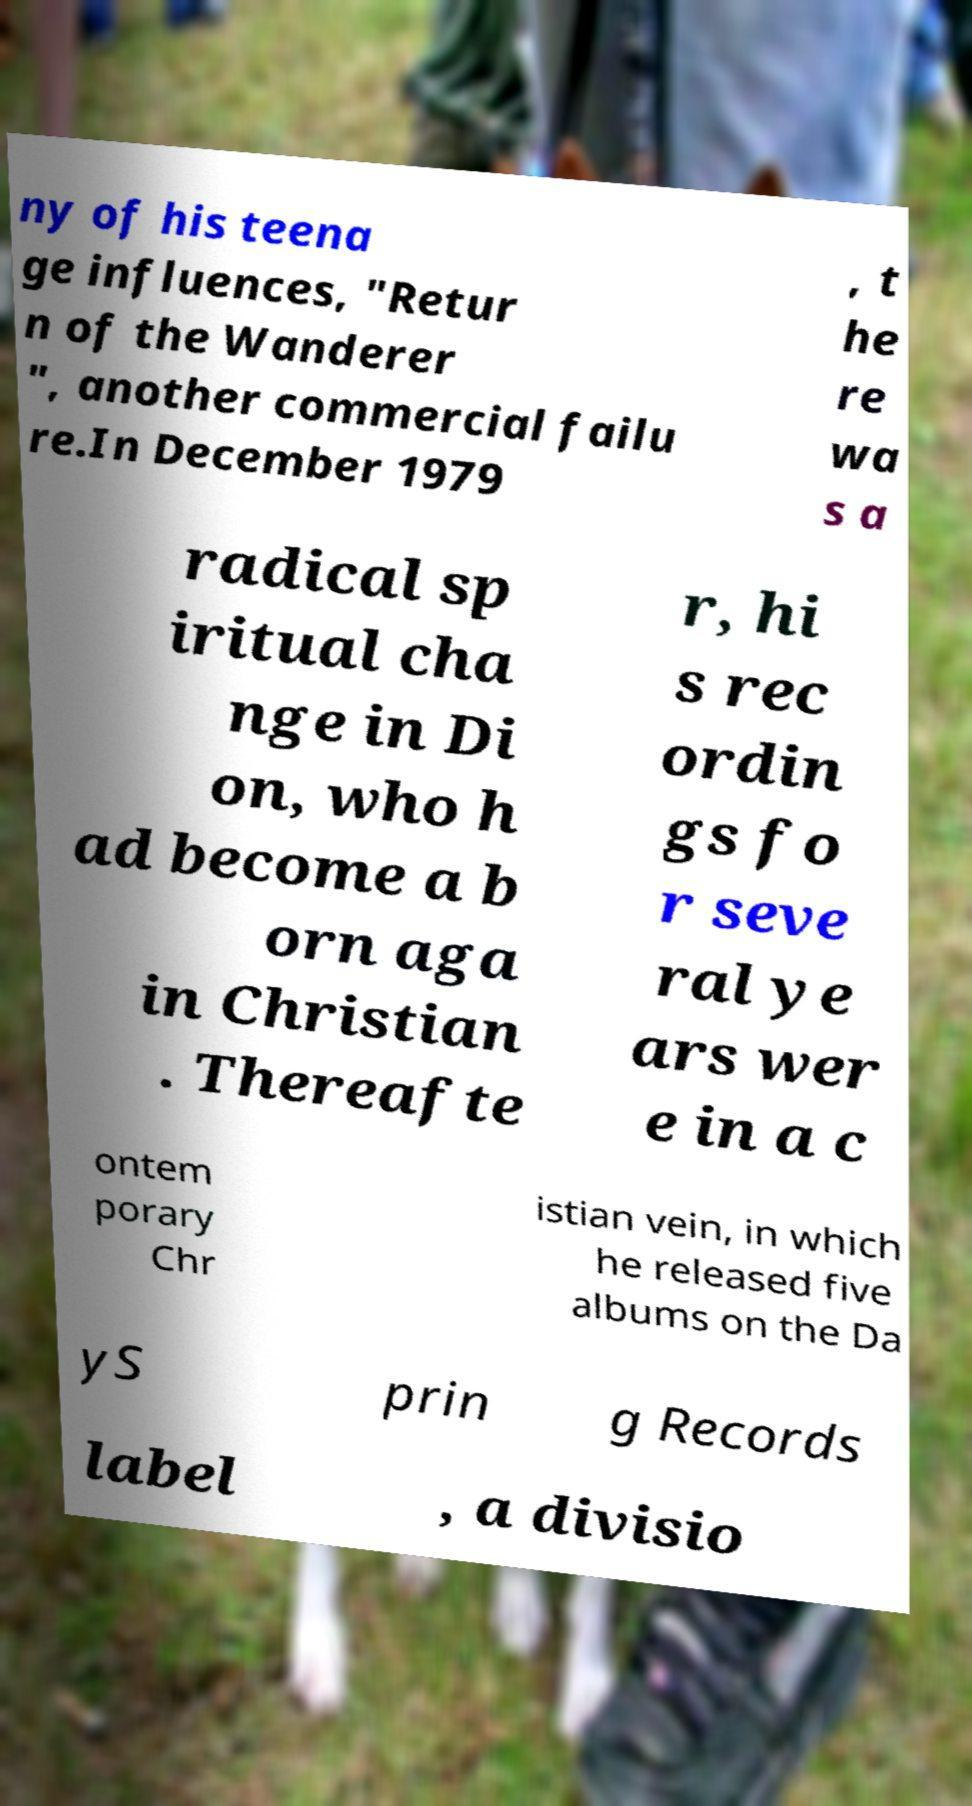Please read and relay the text visible in this image. What does it say? ny of his teena ge influences, "Retur n of the Wanderer ", another commercial failu re.In December 1979 , t he re wa s a radical sp iritual cha nge in Di on, who h ad become a b orn aga in Christian . Thereafte r, hi s rec ordin gs fo r seve ral ye ars wer e in a c ontem porary Chr istian vein, in which he released five albums on the Da yS prin g Records label , a divisio 